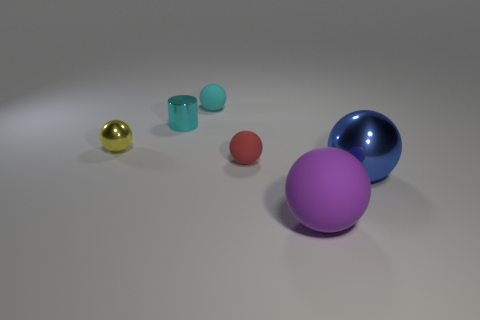There is a small ball behind the yellow metal sphere; are there any tiny yellow metal balls that are to the right of it?
Offer a very short reply. No. The large object in front of the object that is on the right side of the big purple matte ball is what shape?
Your answer should be very brief. Sphere. Are there fewer large blue balls than tiny blue metal blocks?
Provide a succinct answer. No. Are the red object and the small cylinder made of the same material?
Provide a short and direct response. No. What color is the shiny object that is behind the blue shiny object and on the right side of the small yellow sphere?
Offer a very short reply. Cyan. Is there a blue metal thing that has the same size as the cyan shiny thing?
Provide a short and direct response. No. There is a shiny ball to the left of the large blue object that is right of the yellow shiny ball; how big is it?
Your answer should be compact. Small. Is the number of matte objects that are to the right of the tiny yellow metallic object less than the number of tiny yellow metal spheres?
Offer a terse response. No. The purple matte thing is what size?
Your answer should be very brief. Large. How many spheres are the same color as the metal cylinder?
Offer a very short reply. 1. 